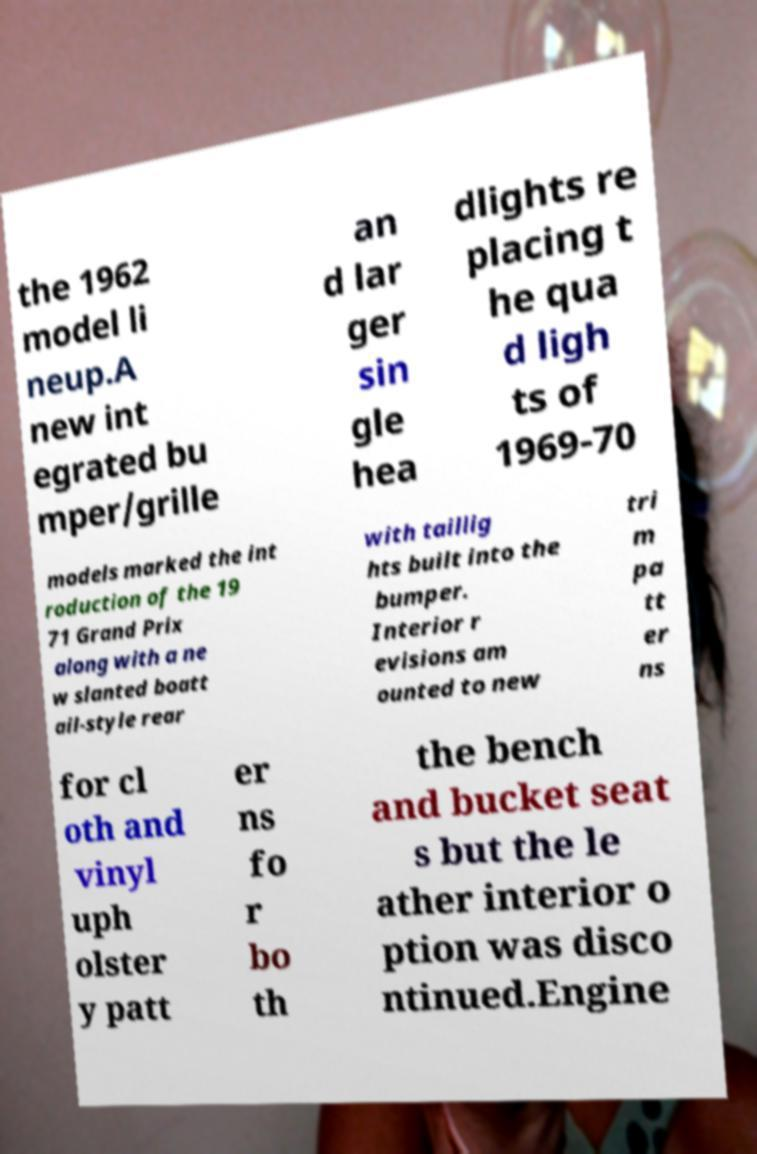What messages or text are displayed in this image? I need them in a readable, typed format. the 1962 model li neup.A new int egrated bu mper/grille an d lar ger sin gle hea dlights re placing t he qua d ligh ts of 1969-70 models marked the int roduction of the 19 71 Grand Prix along with a ne w slanted boatt ail-style rear with taillig hts built into the bumper. Interior r evisions am ounted to new tri m pa tt er ns for cl oth and vinyl uph olster y patt er ns fo r bo th the bench and bucket seat s but the le ather interior o ption was disco ntinued.Engine 